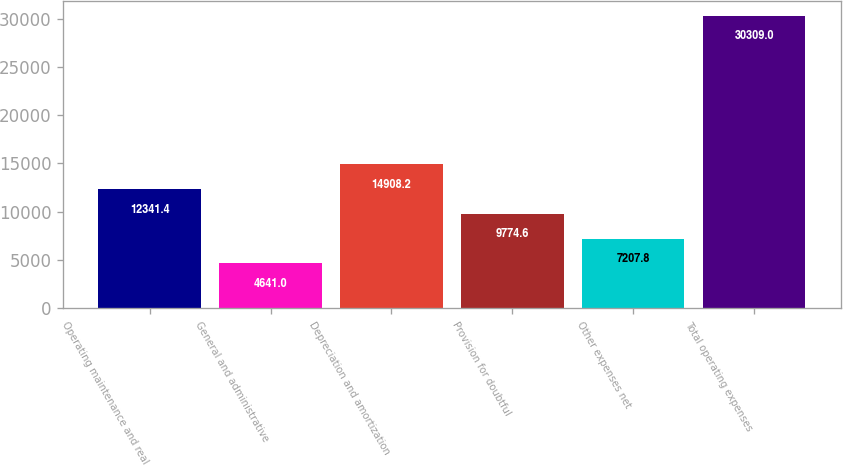Convert chart. <chart><loc_0><loc_0><loc_500><loc_500><bar_chart><fcel>Operating maintenance and real<fcel>General and administrative<fcel>Depreciation and amortization<fcel>Provision for doubtful<fcel>Other expenses net<fcel>Total operating expenses<nl><fcel>12341.4<fcel>4641<fcel>14908.2<fcel>9774.6<fcel>7207.8<fcel>30309<nl></chart> 